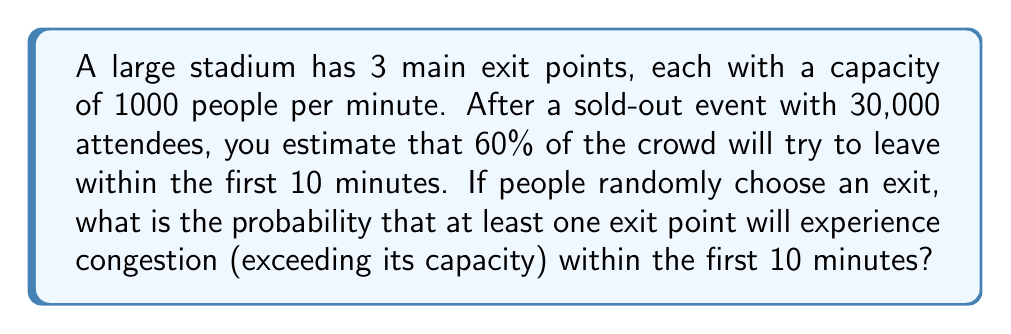What is the answer to this math problem? Let's approach this step-by-step:

1) First, calculate the number of people trying to exit in the first 10 minutes:
   $30,000 \times 0.60 = 18,000$ people

2) The total capacity of all exits in 10 minutes is:
   $3 \times 1000 \times 10 = 30,000$ people

3) If people were evenly distributed, there would be no congestion. However, they choose randomly.

4) The probability of a person choosing any particular exit is $\frac{1}{3}$.

5) We can model this as a binomial distribution for each exit. The number of people at an exit follows $B(18000, \frac{1}{3})$.

6) An exit is congested if it gets more than 10,000 people in 10 minutes.

7) The probability of no congestion at a single exit is:

   $$P(\text{no congestion}) = P(X \leq 10000) = \sum_{k=0}^{10000} \binom{18000}{k} (\frac{1}{3})^k (\frac{2}{3})^{18000-k}$$

8) This is computationally intensive, but we can use the normal approximation to the binomial distribution:

   $\mu = np = 18000 \times \frac{1}{3} = 6000$
   $\sigma = \sqrt{np(1-p)} = \sqrt{18000 \times \frac{1}{3} \times \frac{2}{3}} = \sqrt{4000} = 63.25$

9) Standardizing:
   $z = \frac{10000 - 6000}{63.25} = 63.25$

10) Using a standard normal table or calculator, we find:
    $P(X \leq 10000) \approx 0.9999999999999999$

11) The probability of at least one exit being congested is:
    $1 - (0.9999999999999999)^3 \approx 3 \times 10^{-16}$
Answer: $3 \times 10^{-16}$ 